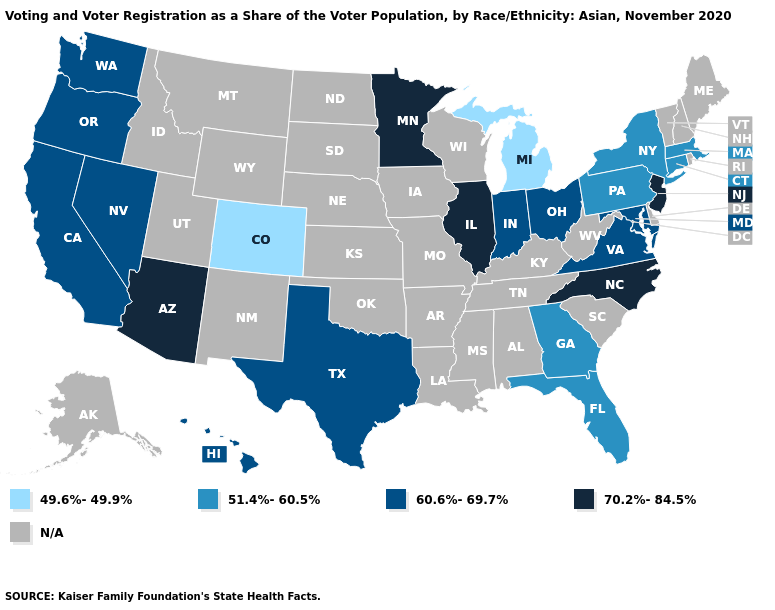What is the value of Michigan?
Give a very brief answer. 49.6%-49.9%. Name the states that have a value in the range N/A?
Quick response, please. Alabama, Alaska, Arkansas, Delaware, Idaho, Iowa, Kansas, Kentucky, Louisiana, Maine, Mississippi, Missouri, Montana, Nebraska, New Hampshire, New Mexico, North Dakota, Oklahoma, Rhode Island, South Carolina, South Dakota, Tennessee, Utah, Vermont, West Virginia, Wisconsin, Wyoming. What is the highest value in the South ?
Write a very short answer. 70.2%-84.5%. Does the first symbol in the legend represent the smallest category?
Short answer required. Yes. Name the states that have a value in the range 51.4%-60.5%?
Keep it brief. Connecticut, Florida, Georgia, Massachusetts, New York, Pennsylvania. What is the highest value in states that border South Dakota?
Keep it brief. 70.2%-84.5%. What is the lowest value in the USA?
Be succinct. 49.6%-49.9%. What is the value of Colorado?
Answer briefly. 49.6%-49.9%. How many symbols are there in the legend?
Concise answer only. 5. What is the value of Rhode Island?
Short answer required. N/A. What is the value of Massachusetts?
Answer briefly. 51.4%-60.5%. Name the states that have a value in the range N/A?
Concise answer only. Alabama, Alaska, Arkansas, Delaware, Idaho, Iowa, Kansas, Kentucky, Louisiana, Maine, Mississippi, Missouri, Montana, Nebraska, New Hampshire, New Mexico, North Dakota, Oklahoma, Rhode Island, South Carolina, South Dakota, Tennessee, Utah, Vermont, West Virginia, Wisconsin, Wyoming. Name the states that have a value in the range 70.2%-84.5%?
Write a very short answer. Arizona, Illinois, Minnesota, New Jersey, North Carolina. Does Hawaii have the highest value in the West?
Be succinct. No. 